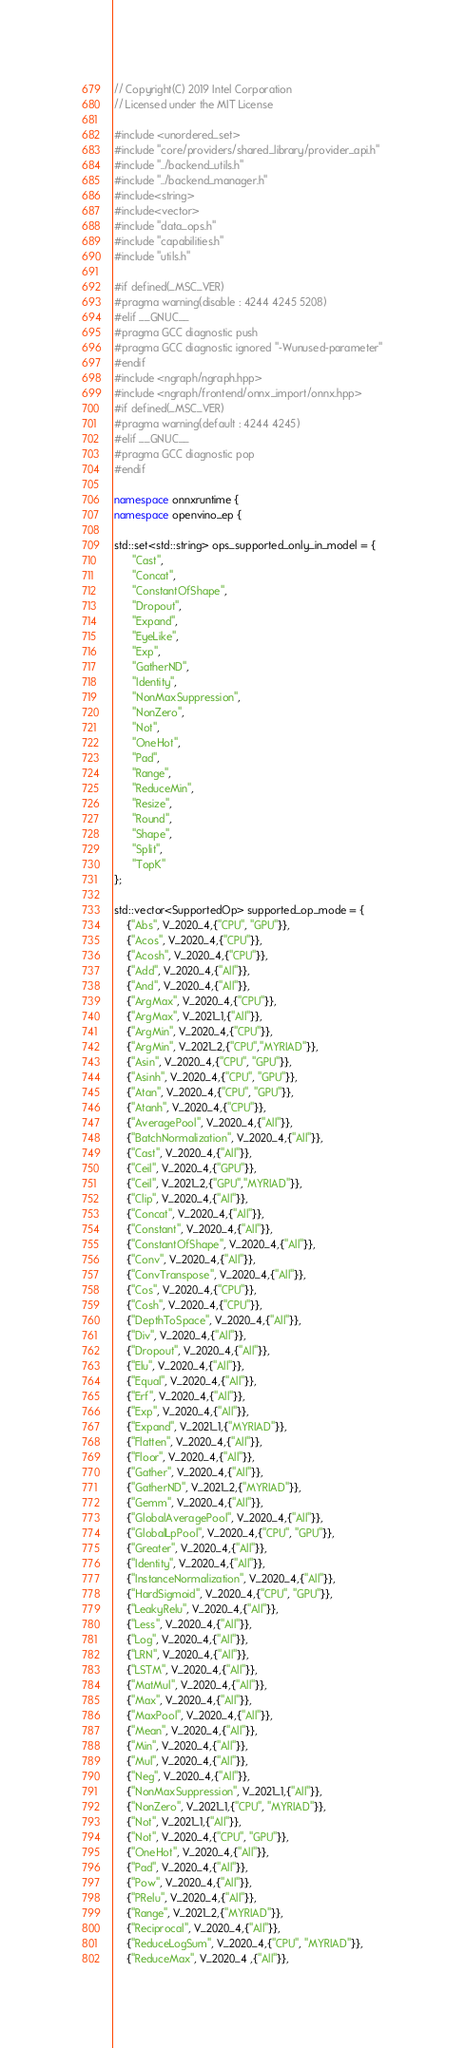Convert code to text. <code><loc_0><loc_0><loc_500><loc_500><_C++_>// Copyright(C) 2019 Intel Corporation
// Licensed under the MIT License

#include <unordered_set>
#include "core/providers/shared_library/provider_api.h"
#include "../backend_utils.h"
#include "../backend_manager.h"
#include<string>
#include<vector>
#include "data_ops.h"
#include "capabilities.h"
#include "utils.h"

#if defined(_MSC_VER)
#pragma warning(disable : 4244 4245 5208)
#elif __GNUC__
#pragma GCC diagnostic push
#pragma GCC diagnostic ignored "-Wunused-parameter"
#endif
#include <ngraph/ngraph.hpp>
#include <ngraph/frontend/onnx_import/onnx.hpp>
#if defined(_MSC_VER)
#pragma warning(default : 4244 4245)
#elif __GNUC__
#pragma GCC diagnostic pop
#endif

namespace onnxruntime {
namespace openvino_ep {

std::set<std::string> ops_supported_only_in_model = {
      "Cast",
      "Concat",
      "ConstantOfShape",
      "Dropout",
      "Expand",
      "EyeLike",
      "Exp",
      "GatherND",
      "Identity",
      "NonMaxSuppression",
      "NonZero",
      "Not",
      "OneHot",
      "Pad",
      "Range",
      "ReduceMin",
      "Resize",
      "Round",
      "Shape",
      "Split",
      "TopK"
}; 

std::vector<SupportedOp> supported_op_mode = {
    {"Abs", V_2020_4,{"CPU", "GPU"}},
    {"Acos", V_2020_4,{"CPU"}},
    {"Acosh", V_2020_4,{"CPU"}},
    {"Add", V_2020_4,{"All"}},
    {"And", V_2020_4,{"All"}},
    {"ArgMax", V_2020_4,{"CPU"}},
    {"ArgMax", V_2021_1,{"All"}},
    {"ArgMin", V_2020_4,{"CPU"}},
    {"ArgMin", V_2021_2,{"CPU","MYRIAD"}},
    {"Asin", V_2020_4,{"CPU", "GPU"}},
    {"Asinh", V_2020_4,{"CPU", "GPU"}},
    {"Atan", V_2020_4,{"CPU", "GPU"}},
    {"Atanh", V_2020_4,{"CPU"}},
    {"AveragePool", V_2020_4,{"All"}},
    {"BatchNormalization", V_2020_4,{"All"}},
    {"Cast", V_2020_4,{"All"}},
    {"Ceil", V_2020_4,{"GPU"}},
    {"Ceil", V_2021_2,{"GPU","MYRIAD"}},
    {"Clip", V_2020_4,{"All"}},
    {"Concat", V_2020_4,{"All"}},
    {"Constant", V_2020_4,{"All"}},
    {"ConstantOfShape", V_2020_4,{"All"}},
    {"Conv", V_2020_4,{"All"}},
    {"ConvTranspose", V_2020_4,{"All"}},
    {"Cos", V_2020_4,{"CPU"}},
    {"Cosh", V_2020_4,{"CPU"}},
    {"DepthToSpace", V_2020_4,{"All"}},
    {"Div", V_2020_4,{"All"}},
    {"Dropout", V_2020_4,{"All"}},
    {"Elu", V_2020_4,{"All"}},
    {"Equal", V_2020_4,{"All"}},
    {"Erf", V_2020_4,{"All"}},
    {"Exp", V_2020_4,{"All"}},
    {"Expand", V_2021_1,{"MYRIAD"}},
    {"Flatten", V_2020_4,{"All"}},
    {"Floor", V_2020_4,{"All"}},
    {"Gather", V_2020_4,{"All"}},
    {"GatherND", V_2021_2,{"MYRIAD"}},
    {"Gemm", V_2020_4,{"All"}},
    {"GlobalAveragePool", V_2020_4,{"All"}},
    {"GlobalLpPool", V_2020_4,{"CPU", "GPU"}},
    {"Greater", V_2020_4,{"All"}},
    {"Identity", V_2020_4,{"All"}},
    {"InstanceNormalization", V_2020_4,{"All"}},
    {"HardSigmoid", V_2020_4,{"CPU", "GPU"}},
    {"LeakyRelu", V_2020_4,{"All"}},
    {"Less", V_2020_4,{"All"}},
    {"Log", V_2020_4,{"All"}},
    {"LRN", V_2020_4,{"All"}},
    {"LSTM", V_2020_4,{"All"}},
    {"MatMul", V_2020_4,{"All"}},
    {"Max", V_2020_4,{"All"}},
    {"MaxPool", V_2020_4,{"All"}},
    {"Mean", V_2020_4,{"All"}},
    {"Min", V_2020_4,{"All"}},
    {"Mul", V_2020_4,{"All"}},
    {"Neg", V_2020_4,{"All"}},
    {"NonMaxSuppression", V_2021_1,{"All"}},
    {"NonZero", V_2021_1,{"CPU", "MYRIAD"}},
    {"Not", V_2021_1,{"All"}},
    {"Not", V_2020_4,{"CPU", "GPU"}},
    {"OneHot", V_2020_4,{"All"}},
    {"Pad", V_2020_4,{"All"}},
    {"Pow", V_2020_4,{"All"}},
    {"PRelu", V_2020_4,{"All"}},
    {"Range", V_2021_2,{"MYRIAD"}},
    {"Reciprocal", V_2020_4,{"All"}},
    {"ReduceLogSum", V_2020_4,{"CPU", "MYRIAD"}},
    {"ReduceMax", V_2020_4 ,{"All"}},</code> 